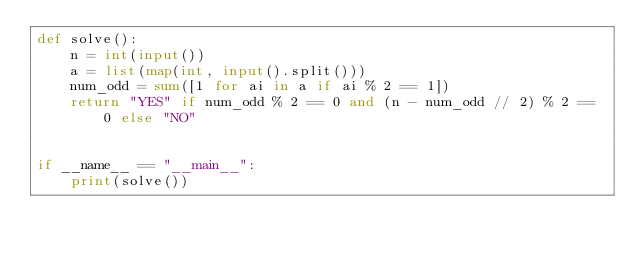<code> <loc_0><loc_0><loc_500><loc_500><_Python_>def solve():
    n = int(input())
    a = list(map(int, input().split()))
    num_odd = sum([1 for ai in a if ai % 2 == 1])
    return "YES" if num_odd % 2 == 0 and (n - num_odd // 2) % 2 == 0 else "NO"


if __name__ == "__main__":
    print(solve())
</code> 